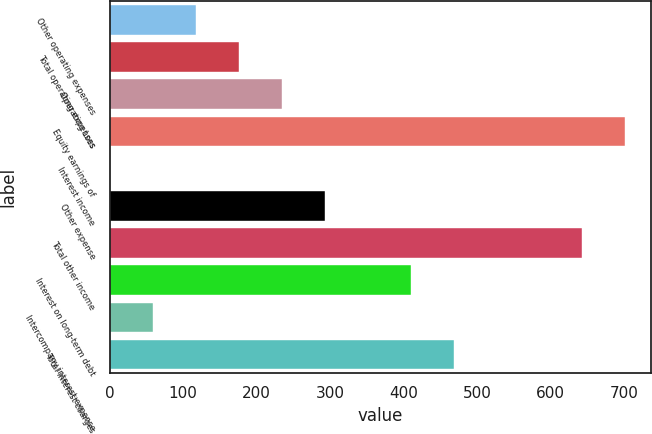Convert chart to OTSL. <chart><loc_0><loc_0><loc_500><loc_500><bar_chart><fcel>Other operating expenses<fcel>Total operating expenses<fcel>Operating Loss<fcel>Equity earnings of<fcel>Interest income<fcel>Other expense<fcel>Total other income<fcel>Interest on long-term debt<fcel>Intercompany interest expense<fcel>Total interest charges<nl><fcel>117.8<fcel>176.2<fcel>234.6<fcel>701.8<fcel>1<fcel>293<fcel>643.4<fcel>409.8<fcel>59.4<fcel>468.2<nl></chart> 